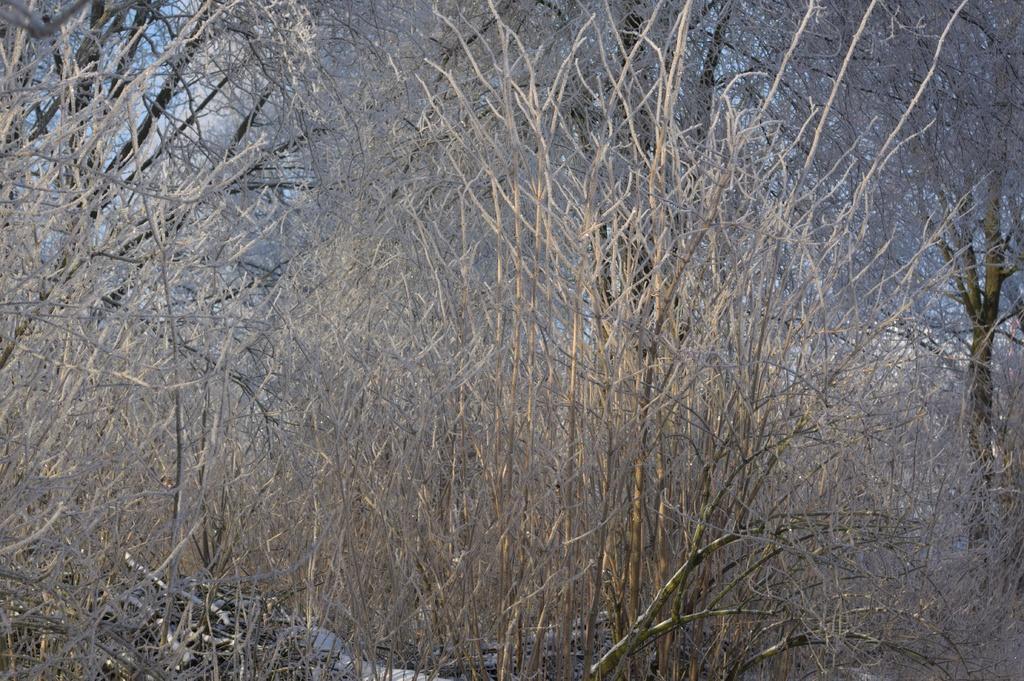Please provide a concise description of this image. In this picture there are few dried trees which has no leaves on it. 